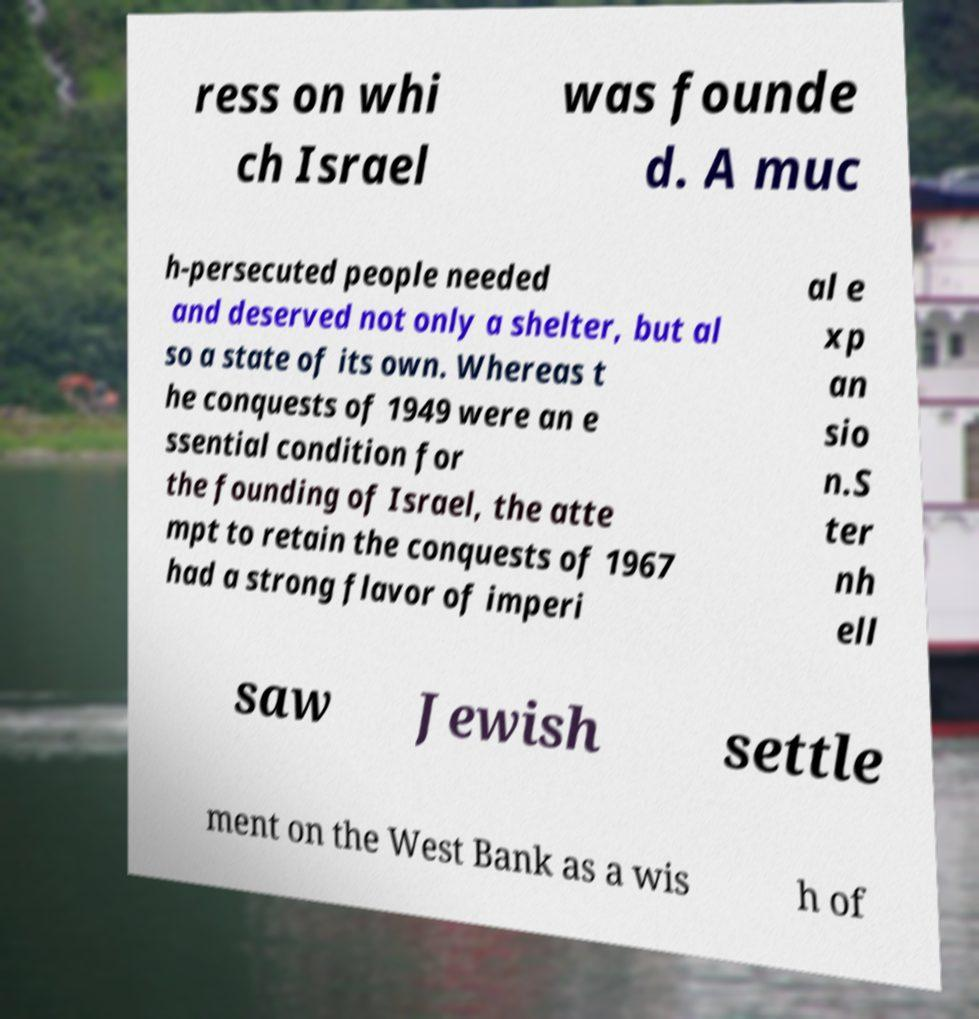Can you read and provide the text displayed in the image?This photo seems to have some interesting text. Can you extract and type it out for me? ress on whi ch Israel was founde d. A muc h-persecuted people needed and deserved not only a shelter, but al so a state of its own. Whereas t he conquests of 1949 were an e ssential condition for the founding of Israel, the atte mpt to retain the conquests of 1967 had a strong flavor of imperi al e xp an sio n.S ter nh ell saw Jewish settle ment on the West Bank as a wis h of 